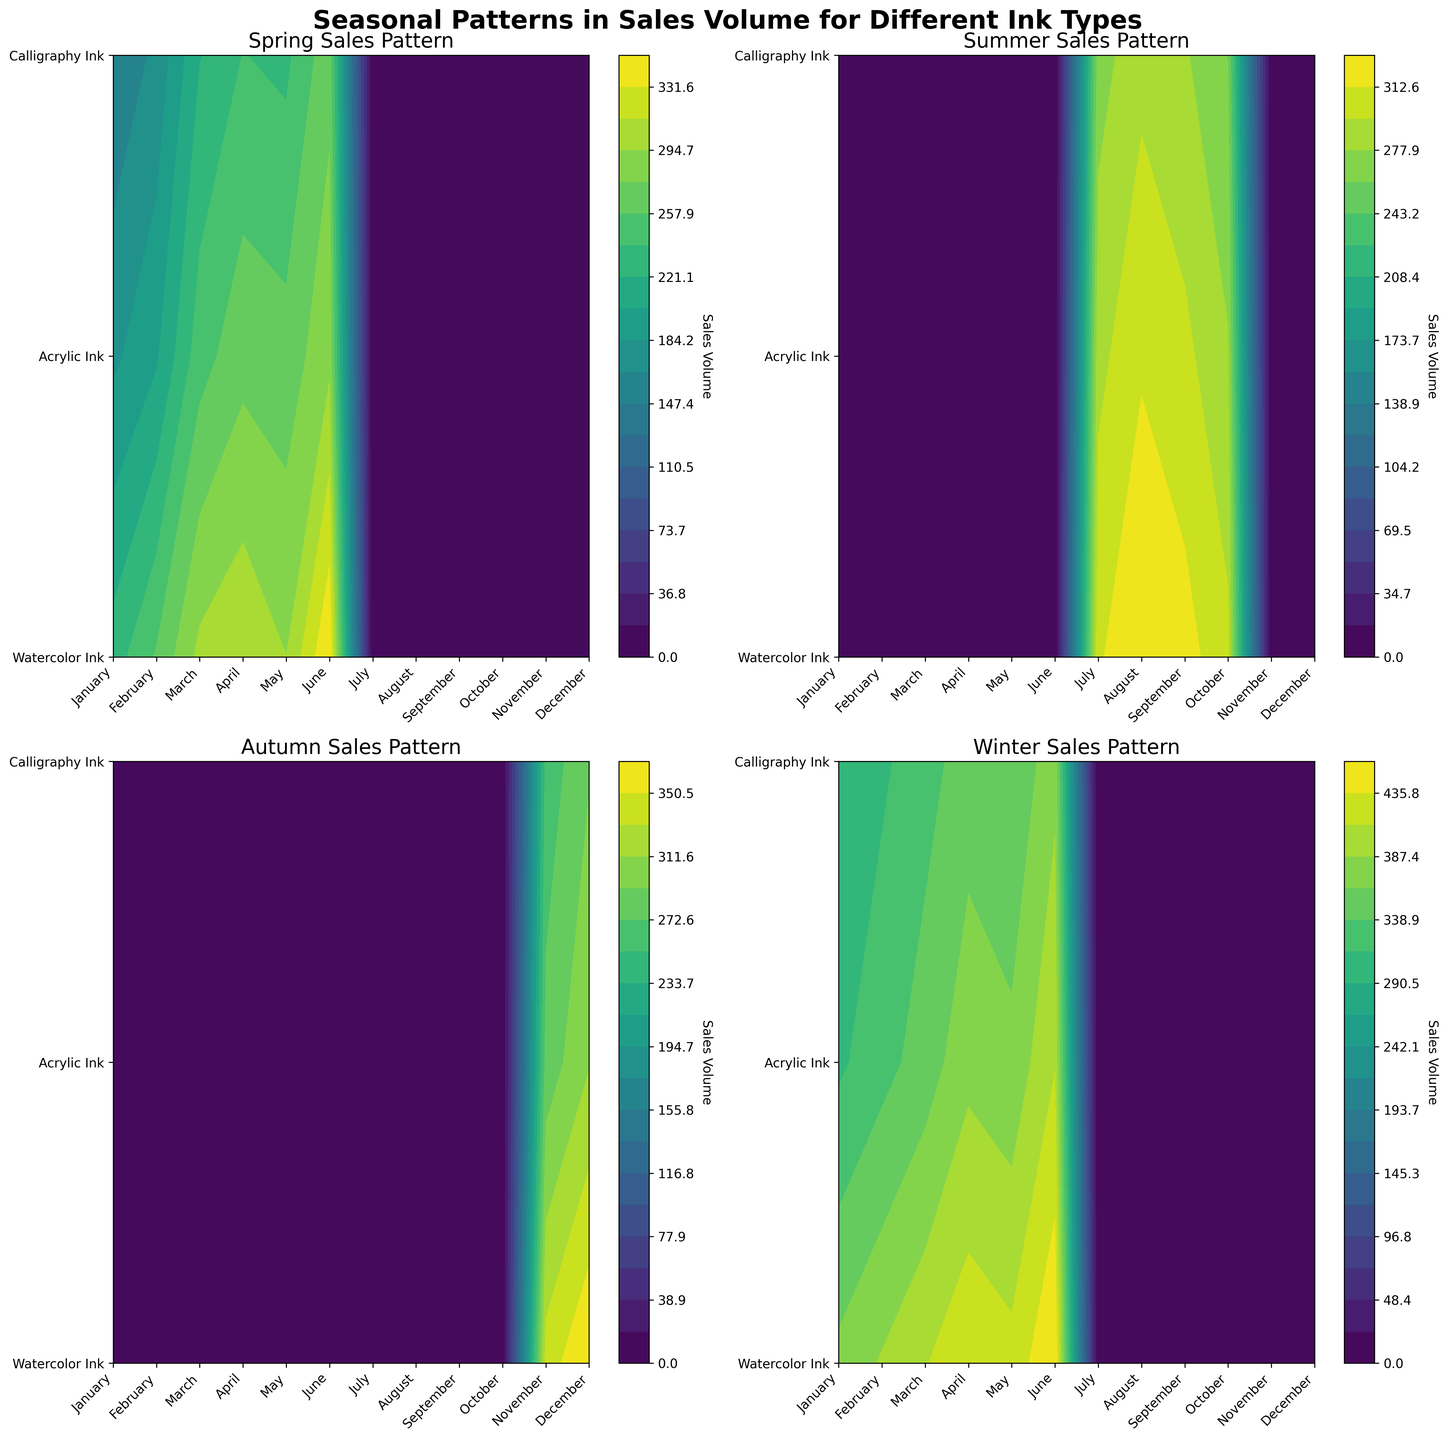Which season has the highest overall sales volume for Watercolor Ink? By analyzing the contour plots, we find that Winter shows the highest sales volume indicated by the darker shades of color.
Answer: Winter During which months is sales data available for Summer sales patterns? In the Summer subplot, sales data is available for July, August, September, and October as indicated on the x-axis.
Answer: July, August, September, and October Compare the sales volume for Calligraphy Ink between Spring and Autumn. Which season has higher sales? In the Spring subplot, the maximum sales volume for Calligraphy Ink is around 270, while in the Autumn subplot it is around 290, indicating higher sales in Autumn.
Answer: Autumn What is the range of sales volume for Acrylic Ink across all seasons? Observing the four subplots, the sales volumes for Acrylic Ink range from 180 to 410.
Answer: 180 to 410 Which ink type has the most evenly distributed sales volume throughout the year? By looking at the contour patterns, Acrylic Ink appears to have a more even distribution throughout the year across the different plots.
Answer: Acrylic Ink In which season does Calligraphy Ink have the lowest sales volume? By examining the contour plots, we see that Calligraphy Ink has the lowest sales volume in Spring, with the lightest shades present there.
Answer: Spring How do the sales volumes for Watercolor Ink in Winter compare to Acrylic Ink in Winter? Winter's contour plot indicates that Watercolor Ink has a higher sales volume ranging up to 460, whereas Acrylic Ink maxes out at 410.
Answer: Watercolor Ink has higher sales in Winter Which season shows a significant increase in sales volume for Acrylic Ink from the beginning to the end of the season? In Winter, the sales volume for Acrylic Ink increases from 310 to 410, as indicated by the progressively darker shades in the contour plot from January to June.
Answer: Winter 